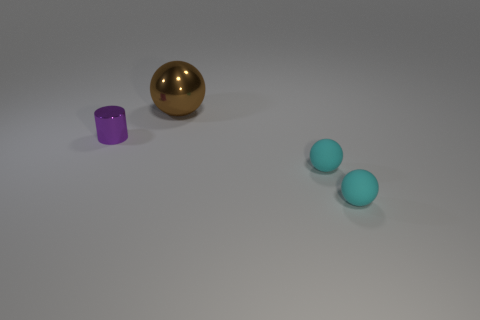Subtract all purple spheres. Subtract all yellow cylinders. How many spheres are left? 3 Add 1 tiny purple cylinders. How many objects exist? 5 Subtract all spheres. How many objects are left? 1 Add 3 purple cylinders. How many purple cylinders are left? 4 Add 2 tiny matte spheres. How many tiny matte spheres exist? 4 Subtract 0 cyan cylinders. How many objects are left? 4 Subtract all big brown spheres. Subtract all big cubes. How many objects are left? 3 